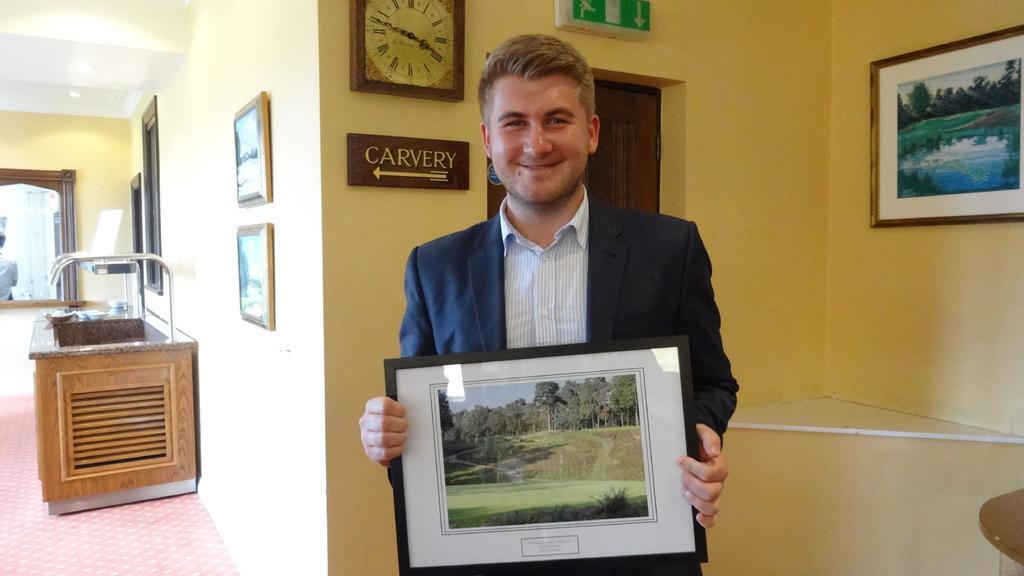Describe this image in one or two sentences. In this image I can see the person wearing the blaze and the shirt and holding the frame. In the background I can see the clock, boards and some frames to the wall. To the left I can see the table and some objects on it. I can also see the mirror to the wall. 